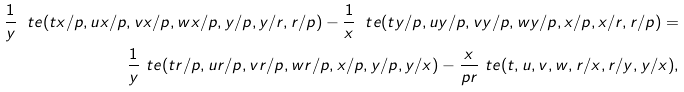<formula> <loc_0><loc_0><loc_500><loc_500>\frac { 1 } { y } \ t e ( t x / p , u x / p , v x / p , w x / p , y / p , y / r , r / p ) - \frac { 1 } { x } \ t e ( t y / p , u y / p , v y / p , w y / p , x / p , x / r , r / p ) = \\ \frac { 1 } { y } \ t e ( t r / p , u r / p , v r / p , w r / p , x / p , y / p , y / x ) - \frac { x } { p r } \ t e ( t , u , v , w , r / x , r / y , y / x ) ,</formula> 